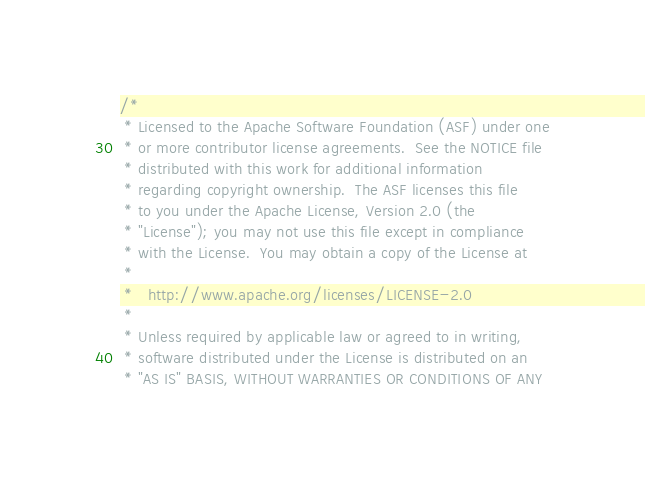<code> <loc_0><loc_0><loc_500><loc_500><_Scala_>/*
 * Licensed to the Apache Software Foundation (ASF) under one
 * or more contributor license agreements.  See the NOTICE file
 * distributed with this work for additional information
 * regarding copyright ownership.  The ASF licenses this file
 * to you under the Apache License, Version 2.0 (the
 * "License"); you may not use this file except in compliance
 * with the License.  You may obtain a copy of the License at
 *
 *   http://www.apache.org/licenses/LICENSE-2.0
 *
 * Unless required by applicable law or agreed to in writing,
 * software distributed under the License is distributed on an
 * "AS IS" BASIS, WITHOUT WARRANTIES OR CONDITIONS OF ANY</code> 